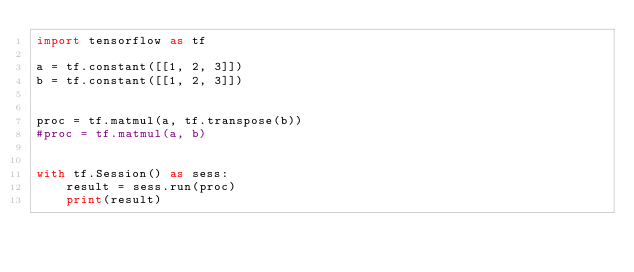<code> <loc_0><loc_0><loc_500><loc_500><_Python_>import tensorflow as tf

a = tf.constant([[1, 2, 3]])
b = tf.constant([[1, 2, 3]])


proc = tf.matmul(a, tf.transpose(b))
#proc = tf.matmul(a, b)


with tf.Session() as sess:
    result = sess.run(proc)
    print(result)
</code> 